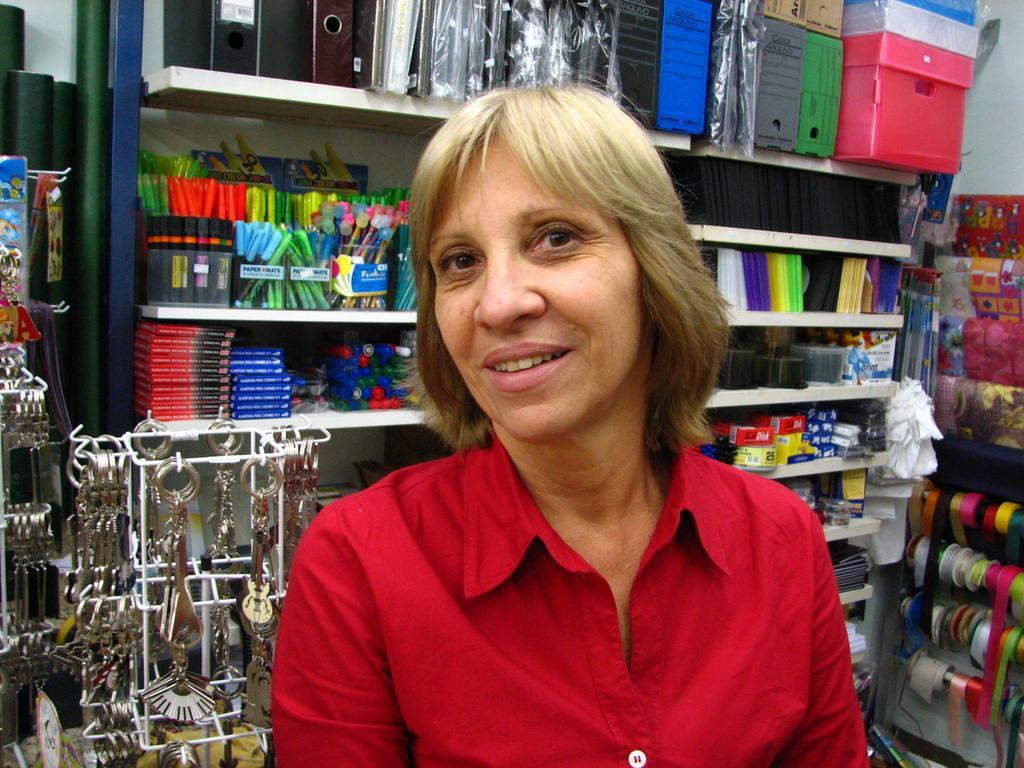In one or two sentences, can you explain what this image depicts? In this image, we can see a person wearing clothes. In the background, we can see a rack contains some objects. There are keychains in the bottom left of the image. There are ribbons in the bottom right of the image. 